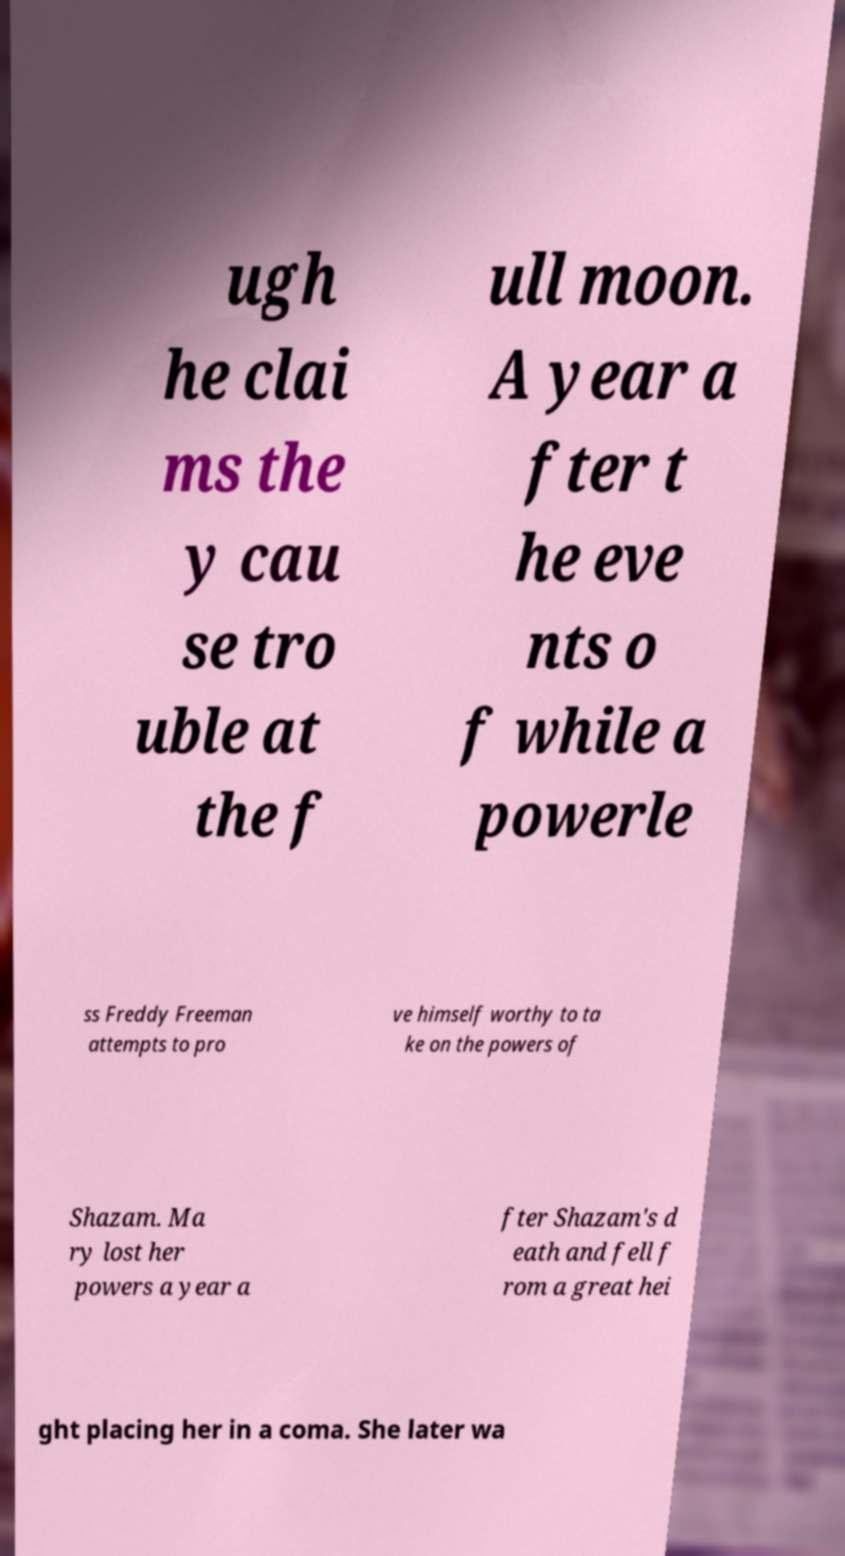I need the written content from this picture converted into text. Can you do that? ugh he clai ms the y cau se tro uble at the f ull moon. A year a fter t he eve nts o f while a powerle ss Freddy Freeman attempts to pro ve himself worthy to ta ke on the powers of Shazam. Ma ry lost her powers a year a fter Shazam's d eath and fell f rom a great hei ght placing her in a coma. She later wa 